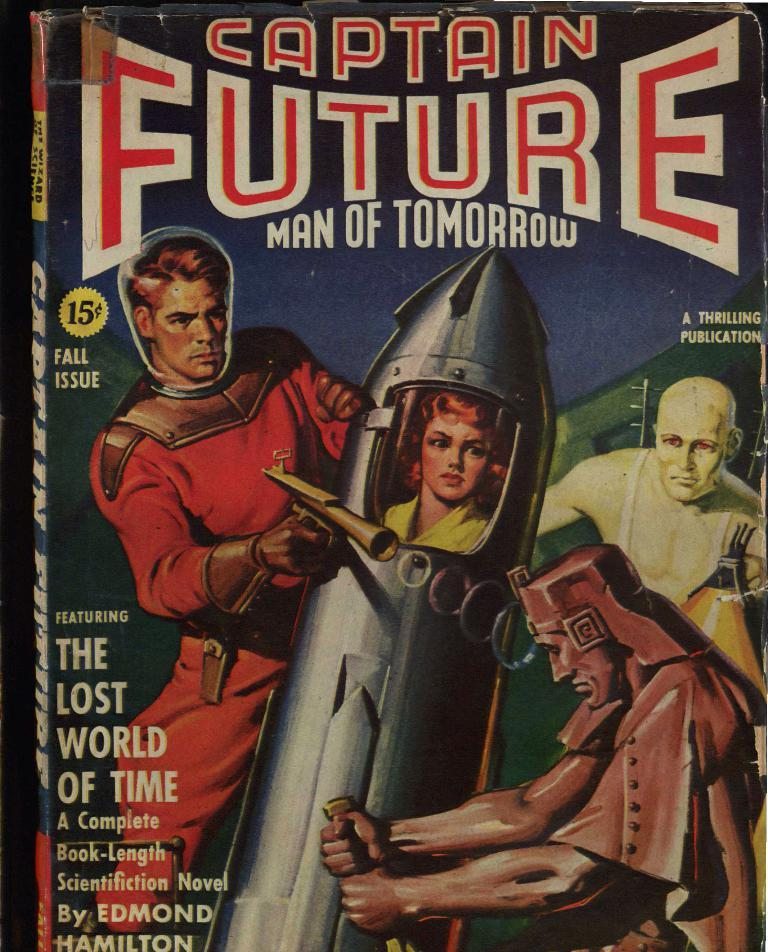Provide a one-sentence caption for the provided image. A book called Captain Future Man of tomorrow. 